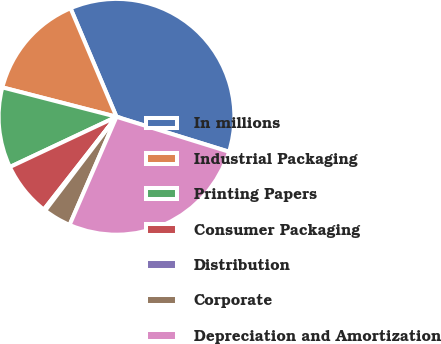Convert chart to OTSL. <chart><loc_0><loc_0><loc_500><loc_500><pie_chart><fcel>In millions<fcel>Industrial Packaging<fcel>Printing Papers<fcel>Consumer Packaging<fcel>Distribution<fcel>Corporate<fcel>Depreciation and Amortization<nl><fcel>36.17%<fcel>14.61%<fcel>11.02%<fcel>7.42%<fcel>0.23%<fcel>3.83%<fcel>26.72%<nl></chart> 